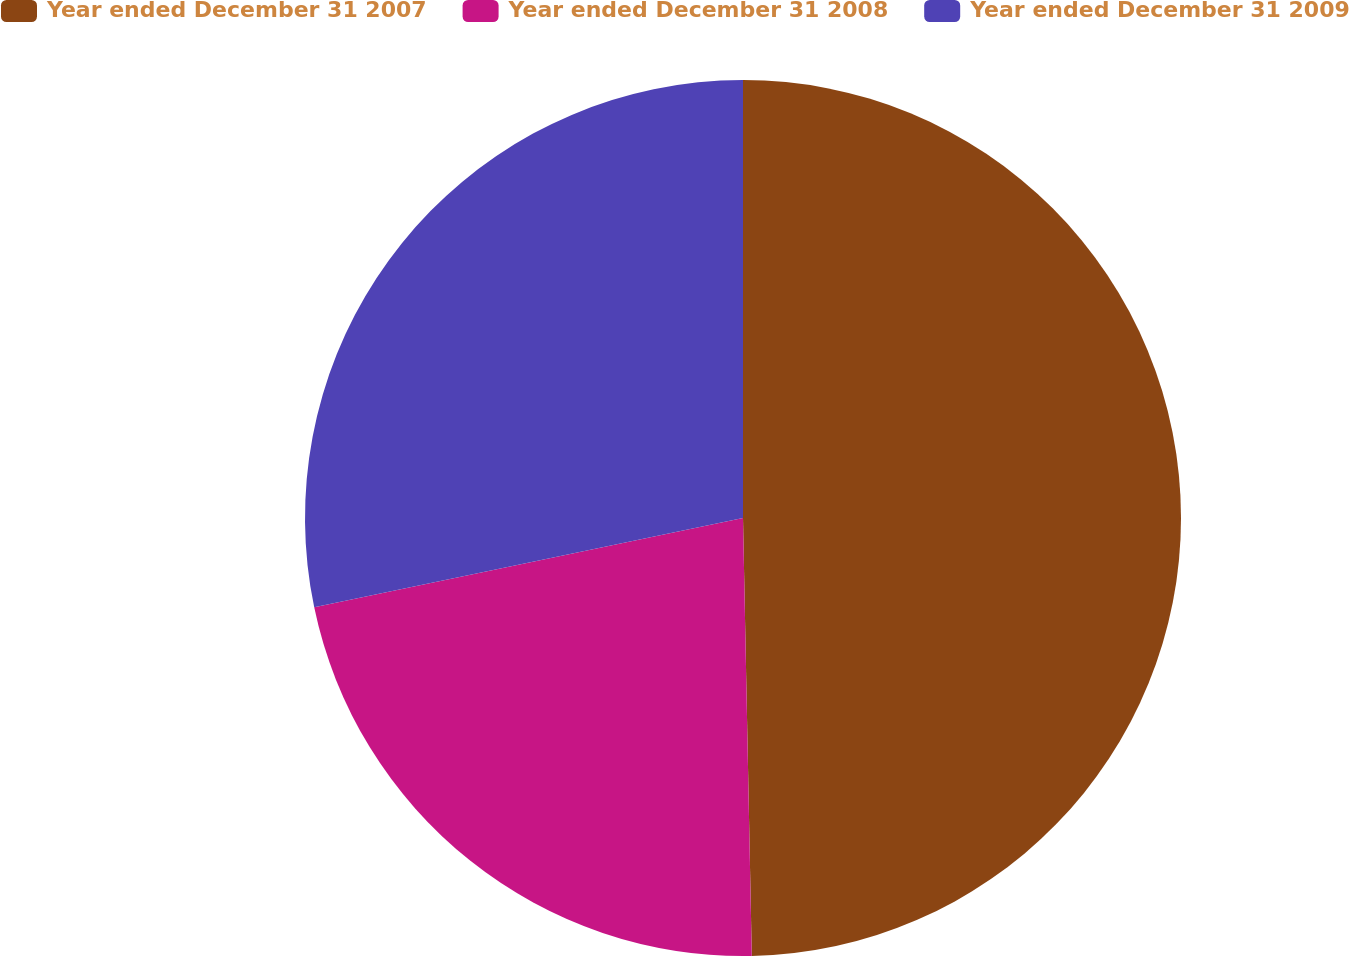<chart> <loc_0><loc_0><loc_500><loc_500><pie_chart><fcel>Year ended December 31 2007<fcel>Year ended December 31 2008<fcel>Year ended December 31 2009<nl><fcel>49.68%<fcel>22.05%<fcel>28.27%<nl></chart> 